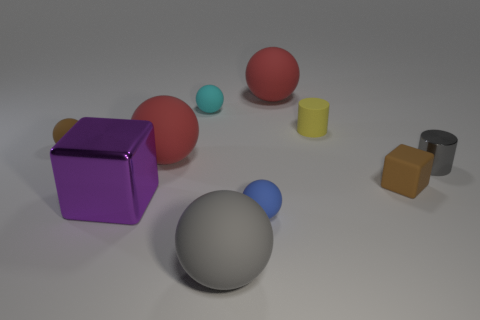Subtract all big red spheres. How many spheres are left? 4 Subtract all gray balls. How many balls are left? 5 Subtract 2 spheres. How many spheres are left? 4 Subtract all gray spheres. Subtract all brown cylinders. How many spheres are left? 5 Subtract all blocks. How many objects are left? 8 Add 8 tiny brown objects. How many tiny brown objects are left? 10 Add 5 matte cubes. How many matte cubes exist? 6 Subtract 1 purple blocks. How many objects are left? 9 Subtract all purple matte cylinders. Subtract all large red rubber spheres. How many objects are left? 8 